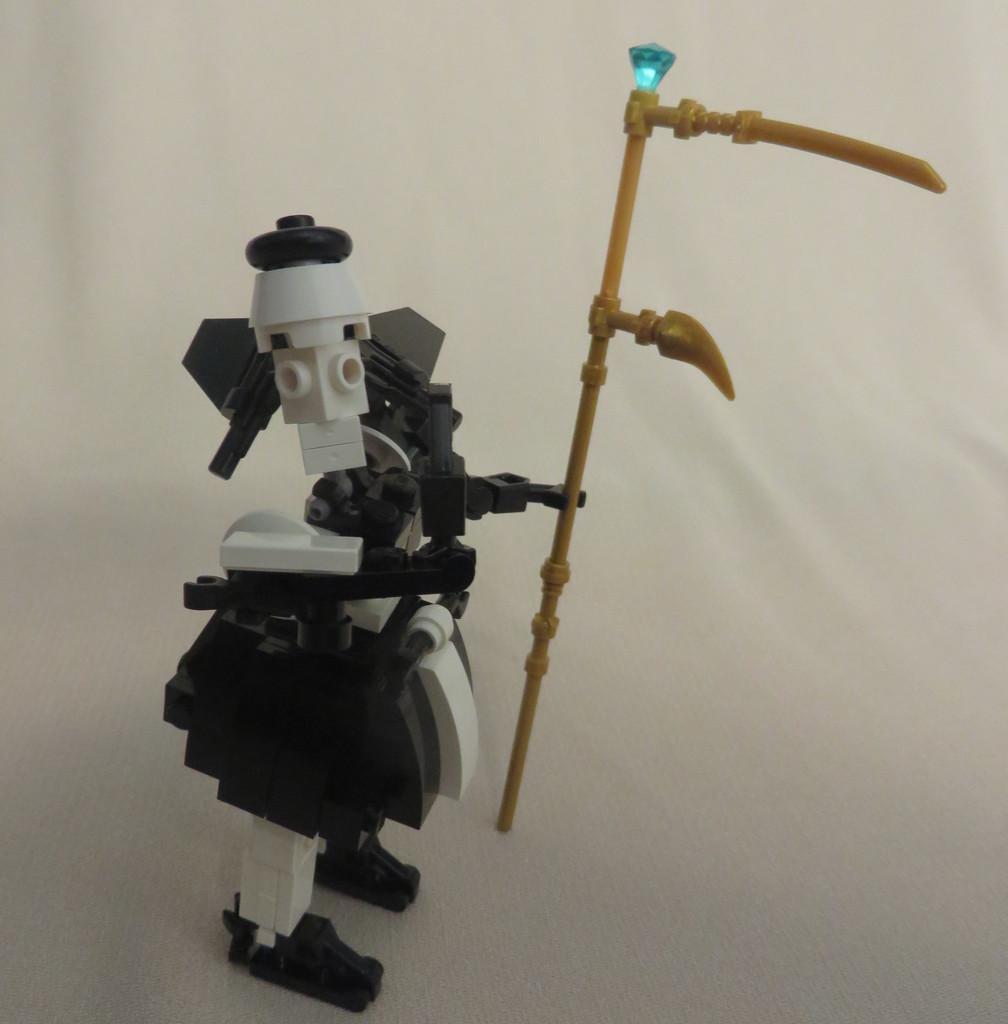In one or two sentences, can you explain what this image depicts? There is a toy made with blocks. It is holding a stick. On that there is a stone. And the background is white. 